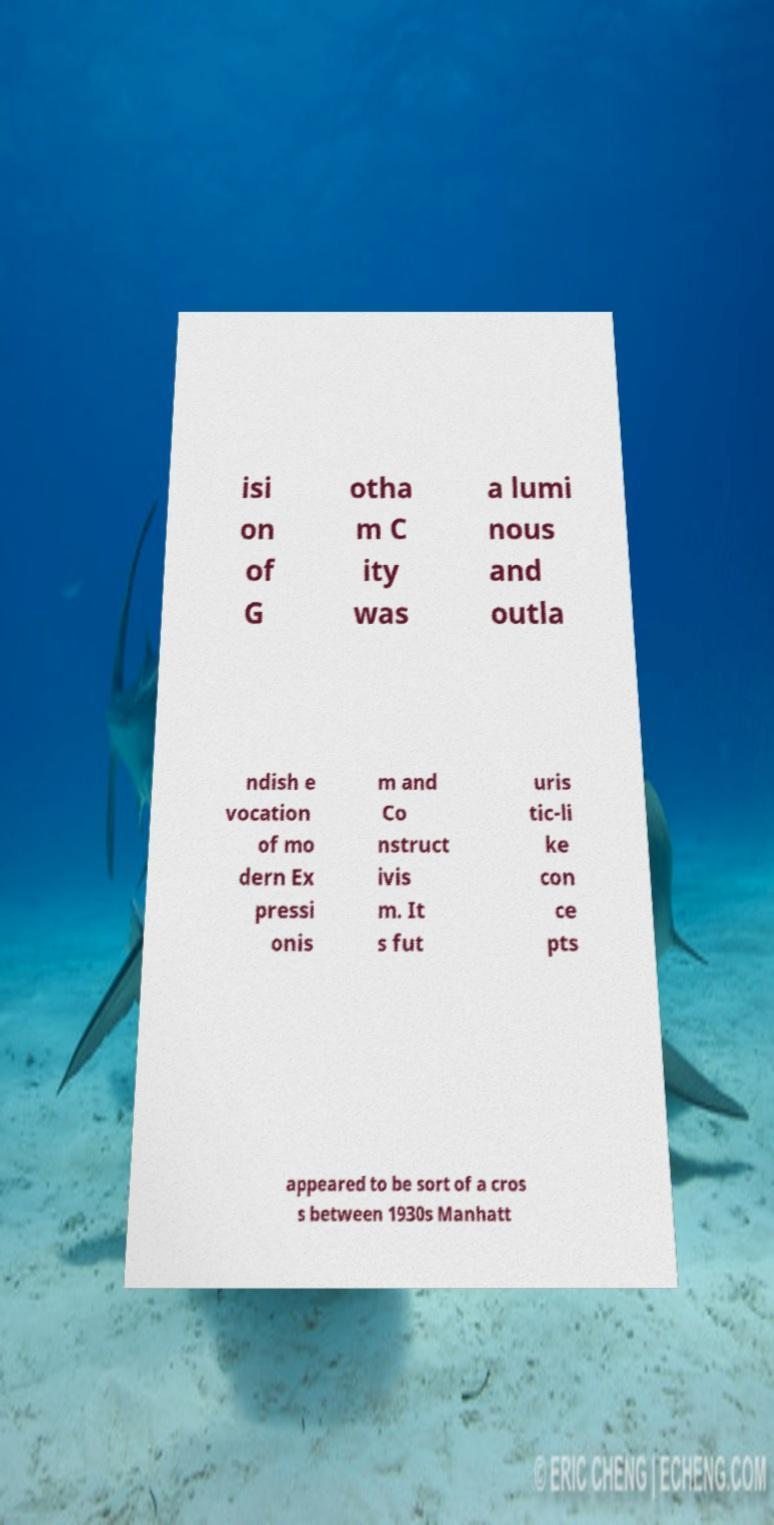Please identify and transcribe the text found in this image. isi on of G otha m C ity was a lumi nous and outla ndish e vocation of mo dern Ex pressi onis m and Co nstruct ivis m. It s fut uris tic-li ke con ce pts appeared to be sort of a cros s between 1930s Manhatt 